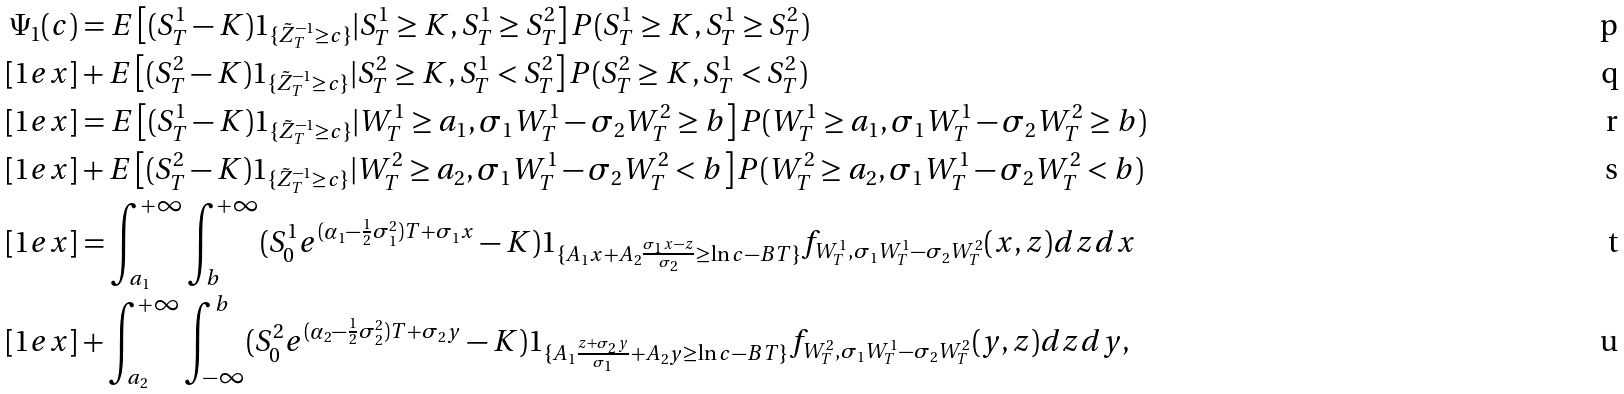Convert formula to latex. <formula><loc_0><loc_0><loc_500><loc_500>\Psi _ { 1 } ( c ) & = E \left [ ( S _ { T } ^ { 1 } - K ) 1 _ { \{ \tilde { Z } ^ { - 1 } _ { T } \geq c \} } | S ^ { 1 } _ { T } \geq K , S ^ { 1 } _ { T } \geq S ^ { 2 } _ { T } \right ] P ( S ^ { 1 } _ { T } \geq K , S ^ { 1 } _ { T } \geq S ^ { 2 } _ { T } ) \\ [ 1 e x ] & + E \left [ ( S _ { T } ^ { 2 } - K ) 1 _ { \{ \tilde { Z } ^ { - 1 } _ { T } \geq c \} } | S ^ { 2 } _ { T } \geq K , S ^ { 1 } _ { T } < S ^ { 2 } _ { T } \right ] P ( S ^ { 2 } _ { T } \geq K , S ^ { 1 } _ { T } < S ^ { 2 } _ { T } ) \\ [ 1 e x ] & = E \left [ ( S _ { T } ^ { 1 } - K ) 1 _ { \{ \tilde { Z } ^ { - 1 } _ { T } \geq c \} } | W ^ { 1 } _ { T } \geq a _ { 1 } , \sigma _ { 1 } W ^ { 1 } _ { T } - \sigma _ { 2 } W ^ { 2 } _ { T } \geq b \right ] P ( W ^ { 1 } _ { T } \geq a _ { 1 } , \sigma _ { 1 } W ^ { 1 } _ { T } - \sigma _ { 2 } W ^ { 2 } _ { T } \geq b ) \\ [ 1 e x ] & + E \left [ ( S _ { T } ^ { 2 } - K ) 1 _ { \{ \tilde { Z } ^ { - 1 } _ { T } \geq c \} } | W ^ { 2 } _ { T } \geq a _ { 2 } , \sigma _ { 1 } W ^ { 1 } _ { T } - \sigma _ { 2 } W ^ { 2 } _ { T } < b \right ] P ( W ^ { 2 } _ { T } \geq a _ { 2 } , \sigma _ { 1 } W ^ { 1 } _ { T } - \sigma _ { 2 } W ^ { 2 } _ { T } < b ) \\ [ 1 e x ] & = \int _ { a _ { 1 } } ^ { + \infty } \int _ { b } ^ { + \infty } ( S ^ { 1 } _ { 0 } e ^ { ( \alpha _ { 1 } - \frac { 1 } { 2 } \sigma _ { 1 } ^ { 2 } ) T + \sigma _ { 1 } x } - K ) 1 _ { \{ A _ { 1 } x + A _ { 2 } \frac { \sigma _ { 1 } x - z } { \sigma _ { 2 } } \geq \ln c - B T \} } f _ { W ^ { 1 } _ { T } , \sigma _ { 1 } W ^ { 1 } _ { T } - \sigma _ { 2 } W ^ { 2 } _ { T } } ( x , z ) d z d x \\ [ 1 e x ] & + \int _ { a _ { 2 } } ^ { + \infty } \int _ { - \infty } ^ { b } ( S ^ { 2 } _ { 0 } e ^ { ( \alpha _ { 2 } - \frac { 1 } { 2 } \sigma _ { 2 } ^ { 2 } ) T + \sigma _ { 2 } y } - K ) 1 _ { \{ A _ { 1 } \frac { z + \sigma _ { 2 } y } { \sigma _ { 1 } } + A _ { 2 } y \geq \ln c - B T \} } f _ { W ^ { 2 } _ { T } , \sigma _ { 1 } W ^ { 1 } _ { T } - \sigma _ { 2 } W ^ { 2 } _ { T } } ( y , z ) d z d y ,</formula> 